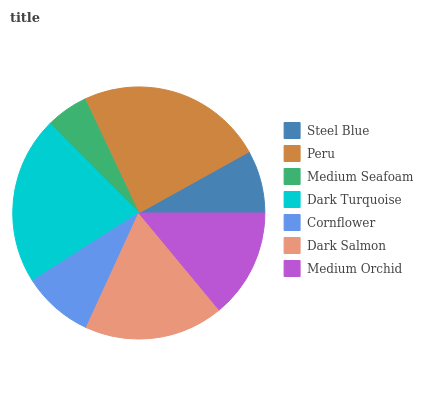Is Medium Seafoam the minimum?
Answer yes or no. Yes. Is Peru the maximum?
Answer yes or no. Yes. Is Peru the minimum?
Answer yes or no. No. Is Medium Seafoam the maximum?
Answer yes or no. No. Is Peru greater than Medium Seafoam?
Answer yes or no. Yes. Is Medium Seafoam less than Peru?
Answer yes or no. Yes. Is Medium Seafoam greater than Peru?
Answer yes or no. No. Is Peru less than Medium Seafoam?
Answer yes or no. No. Is Medium Orchid the high median?
Answer yes or no. Yes. Is Medium Orchid the low median?
Answer yes or no. Yes. Is Steel Blue the high median?
Answer yes or no. No. Is Medium Seafoam the low median?
Answer yes or no. No. 